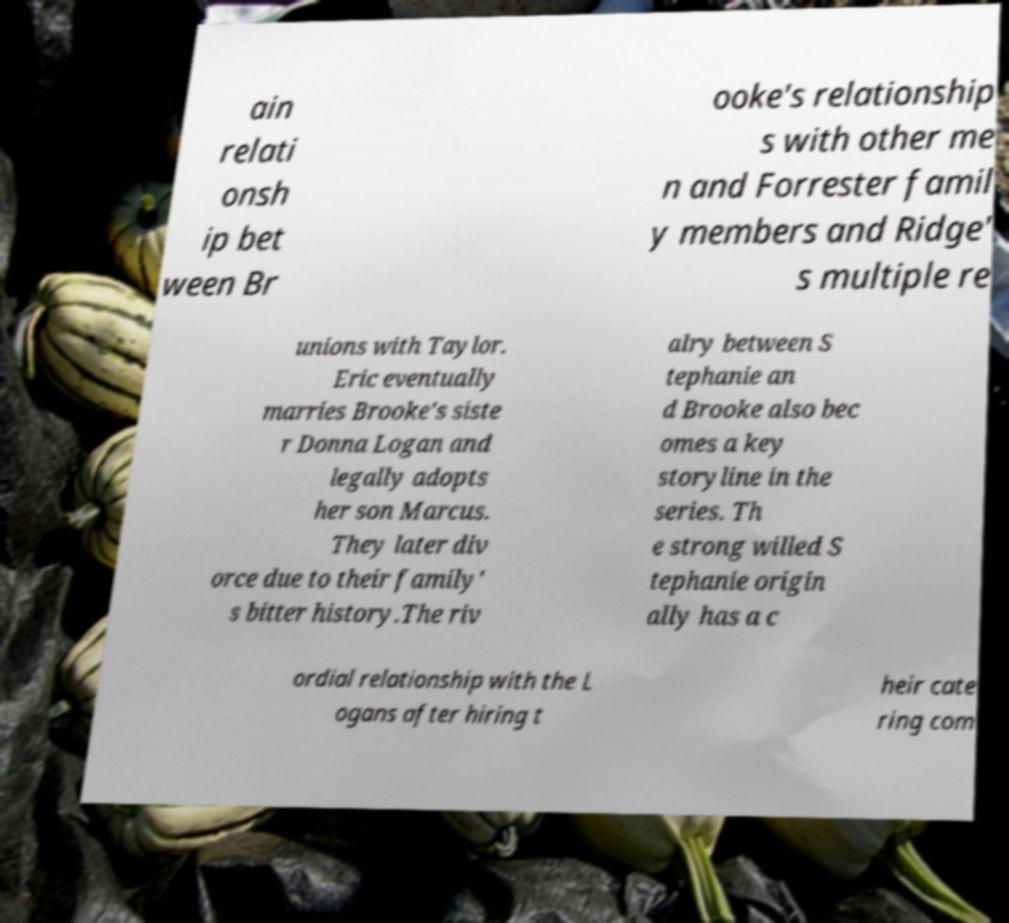I need the written content from this picture converted into text. Can you do that? ain relati onsh ip bet ween Br ooke's relationship s with other me n and Forrester famil y members and Ridge' s multiple re unions with Taylor. Eric eventually marries Brooke's siste r Donna Logan and legally adopts her son Marcus. They later div orce due to their family' s bitter history.The riv alry between S tephanie an d Brooke also bec omes a key storyline in the series. Th e strong willed S tephanie origin ally has a c ordial relationship with the L ogans after hiring t heir cate ring com 